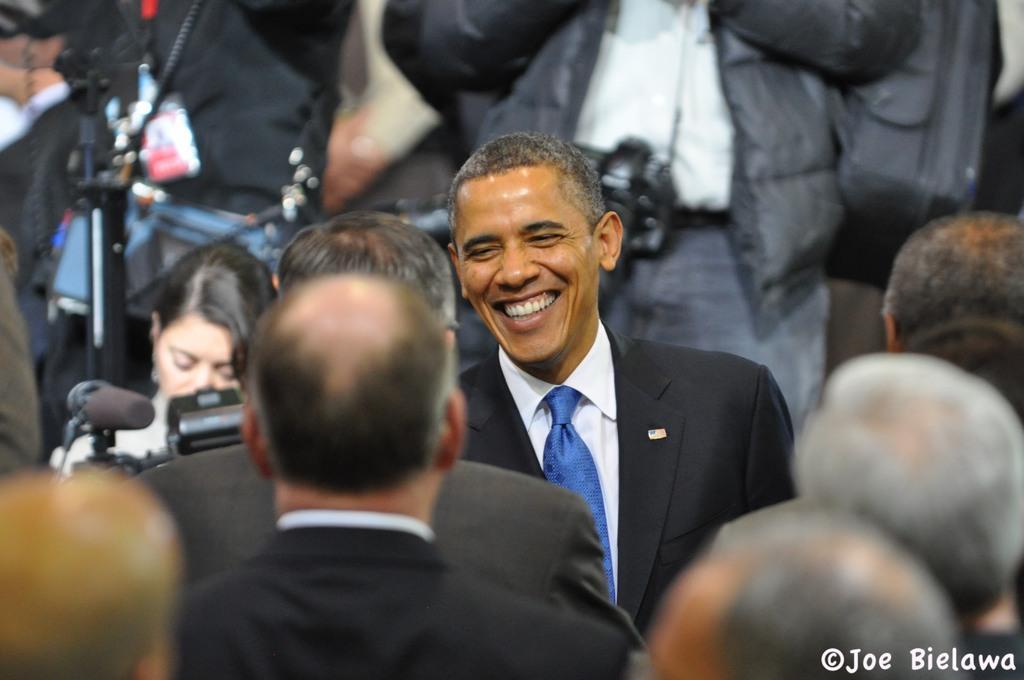In one or two sentences, can you explain what this image depicts? At the center of the image there is Obama, around Obama there are a few people standing and there are cameras and mics around him, at the bottom of the image there is some text. 